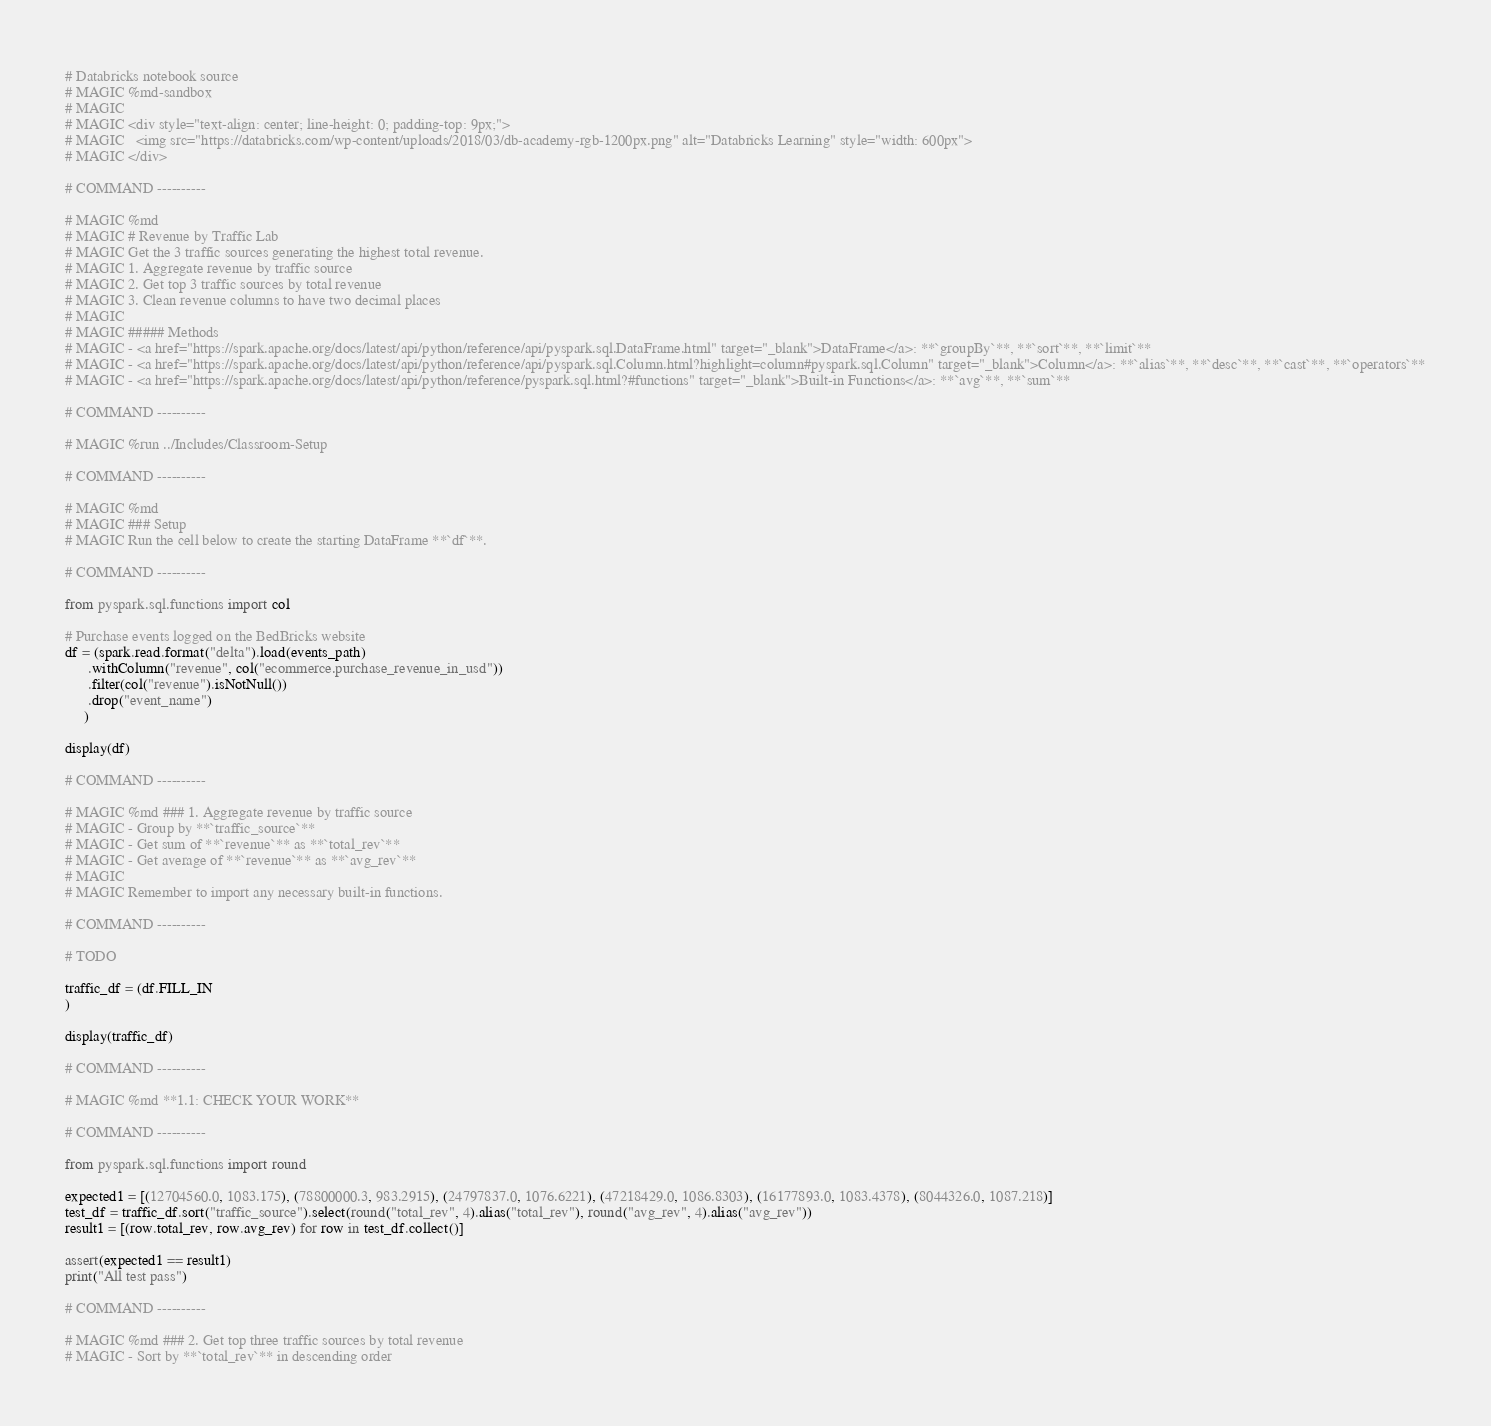Convert code to text. <code><loc_0><loc_0><loc_500><loc_500><_Python_># Databricks notebook source
# MAGIC %md-sandbox
# MAGIC 
# MAGIC <div style="text-align: center; line-height: 0; padding-top: 9px;">
# MAGIC   <img src="https://databricks.com/wp-content/uploads/2018/03/db-academy-rgb-1200px.png" alt="Databricks Learning" style="width: 600px">
# MAGIC </div>

# COMMAND ----------

# MAGIC %md
# MAGIC # Revenue by Traffic Lab
# MAGIC Get the 3 traffic sources generating the highest total revenue.
# MAGIC 1. Aggregate revenue by traffic source
# MAGIC 2. Get top 3 traffic sources by total revenue
# MAGIC 3. Clean revenue columns to have two decimal places
# MAGIC 
# MAGIC ##### Methods
# MAGIC - <a href="https://spark.apache.org/docs/latest/api/python/reference/api/pyspark.sql.DataFrame.html" target="_blank">DataFrame</a>: **`groupBy`**, **`sort`**, **`limit`**
# MAGIC - <a href="https://spark.apache.org/docs/latest/api/python/reference/api/pyspark.sql.Column.html?highlight=column#pyspark.sql.Column" target="_blank">Column</a>: **`alias`**, **`desc`**, **`cast`**, **`operators`**
# MAGIC - <a href="https://spark.apache.org/docs/latest/api/python/reference/pyspark.sql.html?#functions" target="_blank">Built-in Functions</a>: **`avg`**, **`sum`**

# COMMAND ----------

# MAGIC %run ../Includes/Classroom-Setup

# COMMAND ----------

# MAGIC %md
# MAGIC ### Setup
# MAGIC Run the cell below to create the starting DataFrame **`df`**.

# COMMAND ----------

from pyspark.sql.functions import col

# Purchase events logged on the BedBricks website
df = (spark.read.format("delta").load(events_path)
      .withColumn("revenue", col("ecommerce.purchase_revenue_in_usd"))
      .filter(col("revenue").isNotNull())
      .drop("event_name")
     )

display(df)

# COMMAND ----------

# MAGIC %md ### 1. Aggregate revenue by traffic source
# MAGIC - Group by **`traffic_source`**
# MAGIC - Get sum of **`revenue`** as **`total_rev`**
# MAGIC - Get average of **`revenue`** as **`avg_rev`**
# MAGIC 
# MAGIC Remember to import any necessary built-in functions.

# COMMAND ----------

# TODO

traffic_df = (df.FILL_IN
)

display(traffic_df)

# COMMAND ----------

# MAGIC %md **1.1: CHECK YOUR WORK**

# COMMAND ----------

from pyspark.sql.functions import round

expected1 = [(12704560.0, 1083.175), (78800000.3, 983.2915), (24797837.0, 1076.6221), (47218429.0, 1086.8303), (16177893.0, 1083.4378), (8044326.0, 1087.218)]
test_df = traffic_df.sort("traffic_source").select(round("total_rev", 4).alias("total_rev"), round("avg_rev", 4).alias("avg_rev"))
result1 = [(row.total_rev, row.avg_rev) for row in test_df.collect()]

assert(expected1 == result1)
print("All test pass")

# COMMAND ----------

# MAGIC %md ### 2. Get top three traffic sources by total revenue
# MAGIC - Sort by **`total_rev`** in descending order</code> 